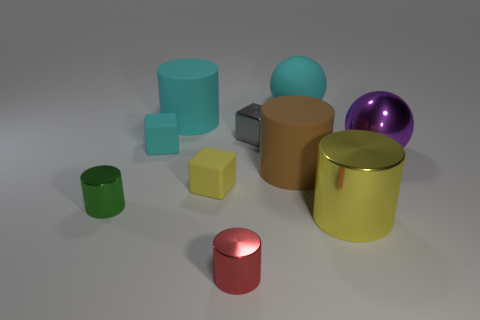What number of small things are either yellow objects or cylinders?
Keep it short and to the point. 3. The cube that is the same color as the big matte sphere is what size?
Provide a succinct answer. Small. Are there any gray things made of the same material as the big cyan ball?
Your answer should be compact. No. There is a big thing on the left side of the red object; what material is it?
Ensure brevity in your answer.  Rubber. There is a big thing that is left of the red metallic cylinder; is its color the same as the large ball behind the tiny metallic cube?
Offer a terse response. Yes. What color is the rubber object that is the same size as the cyan rubber block?
Provide a succinct answer. Yellow. What number of other things are the same shape as the big brown rubber thing?
Offer a terse response. 4. There is a metal object behind the large metal ball; how big is it?
Your response must be concise. Small. There is a tiny metal object in front of the yellow shiny thing; how many purple spheres are behind it?
Your answer should be compact. 1. What number of other things are the same size as the metal cube?
Keep it short and to the point. 4. 